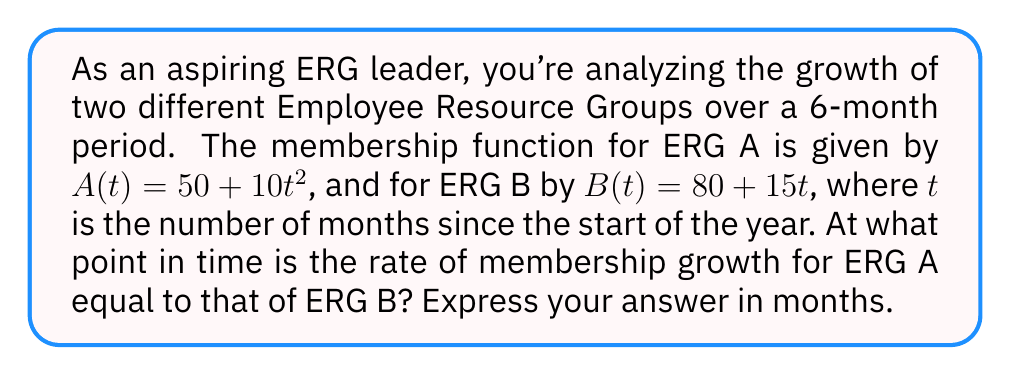Help me with this question. Let's approach this step-by-step:

1) First, we need to find the rate of change (derivative) for each ERG's membership function:

   For ERG A: $A'(t) = \frac{d}{dt}(50 + 10t^2) = 20t$
   For ERG B: $B'(t) = \frac{d}{dt}(80 + 15t) = 15$

2) The question asks when these rates are equal, so we set up the equation:

   $A'(t) = B'(t)$
   $20t = 15$

3) Now we solve for $t$:

   $t = \frac{15}{20} = \frac{3}{4} = 0.75$

4) The question asks for the answer in months, and 0.75 months is equal to 3/4 of a month.

Therefore, the rate of membership growth for ERG A equals that of ERG B after 3/4 of a month, or 0.75 months.
Answer: 0.75 months 